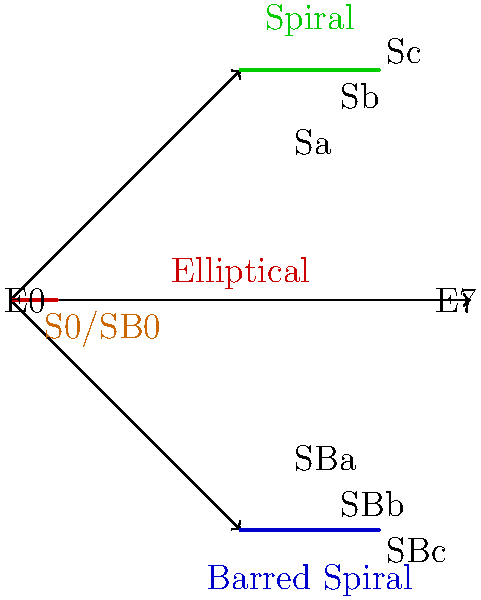As a technology director considering the implementation of an automated galaxy classification system, which type of galaxy in Hubble's tuning fork diagram would likely present the most challenges for accurate machine learning classification, and why? To answer this question, let's consider the characteristics of each galaxy type in Hubble's tuning fork diagram and the challenges they might present for machine learning classification:

1. Elliptical galaxies (E0-E7):
   - Relatively simple structure
   - Varying degrees of ellipticity
   - Lack of distinct features

2. Spiral galaxies (Sa, Sb, Sc):
   - Clear spiral arm structure
   - Varying arm tightness and prominence
   - Presence of a central bulge

3. Barred spiral galaxies (SBa, SBb, SBc):
   - Similar to regular spirals but with a bar-like structure through the center
   - Varying arm tightness and prominence
   - Bar length and strength can differ

4. Lenticular galaxies (S0/SB0):
   - Intermediate between elliptical and spiral galaxies
   - Disk-like structure but no spiral arms
   - May have a small bulge or bar

Among these types, the lenticular galaxies (S0/SB0) would likely present the most challenges for accurate machine learning classification:

1. Ambiguous features: They share characteristics with both elliptical and spiral galaxies, making them harder to distinguish.
2. Lack of distinct structural elements: Unlike spirals with clear arms or ellipticals with consistent shapes, lenticulars have subtle features.
3. Potential confusion: They could be misclassified as either ellipticals or face-on spirals without clear arms.
4. Rarity: They are less common than ellipticals or spirals, potentially leading to imbalanced training data.
5. Variability: The presence or absence of a small bulge or bar adds another layer of complexity.

These factors would require more sophisticated algorithms, larger and more diverse training datasets, and potentially more computational resources to achieve accurate classification, aligning with the need for careful planning and risk assessment in technology implementation.
Answer: Lenticular galaxies (S0/SB0) 